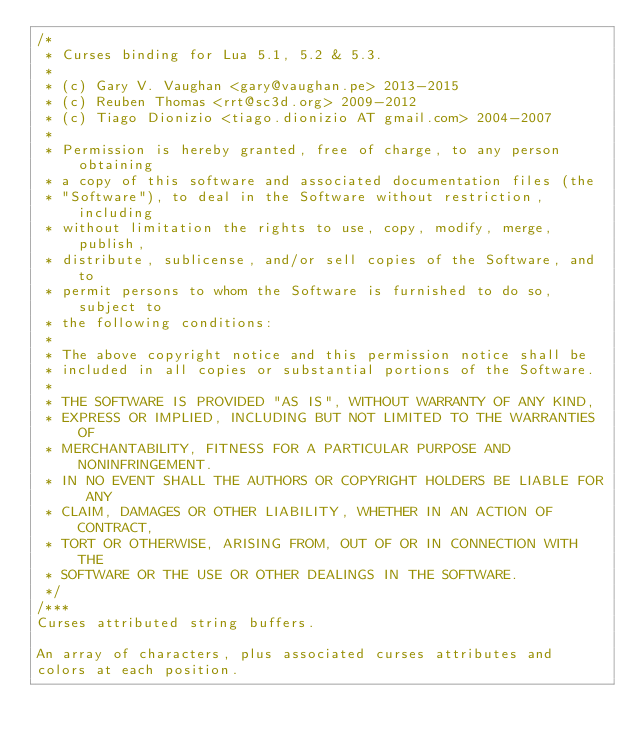Convert code to text. <code><loc_0><loc_0><loc_500><loc_500><_C_>/*
 * Curses binding for Lua 5.1, 5.2 & 5.3.
 *
 * (c) Gary V. Vaughan <gary@vaughan.pe> 2013-2015
 * (c) Reuben Thomas <rrt@sc3d.org> 2009-2012
 * (c) Tiago Dionizio <tiago.dionizio AT gmail.com> 2004-2007
 *
 * Permission is hereby granted, free of charge, to any person obtaining
 * a copy of this software and associated documentation files (the
 * "Software"), to deal in the Software without restriction, including
 * without limitation the rights to use, copy, modify, merge, publish,
 * distribute, sublicense, and/or sell copies of the Software, and to
 * permit persons to whom the Software is furnished to do so, subject to
 * the following conditions:
 *
 * The above copyright notice and this permission notice shall be
 * included in all copies or substantial portions of the Software.
 *
 * THE SOFTWARE IS PROVIDED "AS IS", WITHOUT WARRANTY OF ANY KIND,
 * EXPRESS OR IMPLIED, INCLUDING BUT NOT LIMITED TO THE WARRANTIES OF
 * MERCHANTABILITY, FITNESS FOR A PARTICULAR PURPOSE AND NONINFRINGEMENT.
 * IN NO EVENT SHALL THE AUTHORS OR COPYRIGHT HOLDERS BE LIABLE FOR ANY
 * CLAIM, DAMAGES OR OTHER LIABILITY, WHETHER IN AN ACTION OF CONTRACT,
 * TORT OR OTHERWISE, ARISING FROM, OUT OF OR IN CONNECTION WITH THE
 * SOFTWARE OR THE USE OR OTHER DEALINGS IN THE SOFTWARE.
 */
/***
Curses attributed string buffers.

An array of characters, plus associated curses attributes and
colors at each position.
</code> 